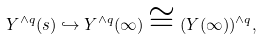<formula> <loc_0><loc_0><loc_500><loc_500>Y ^ { \wedge q } ( s ) \hookrightarrow Y ^ { \wedge q } ( \infty ) \cong ( Y ( \infty ) ) ^ { \wedge q } ,</formula> 